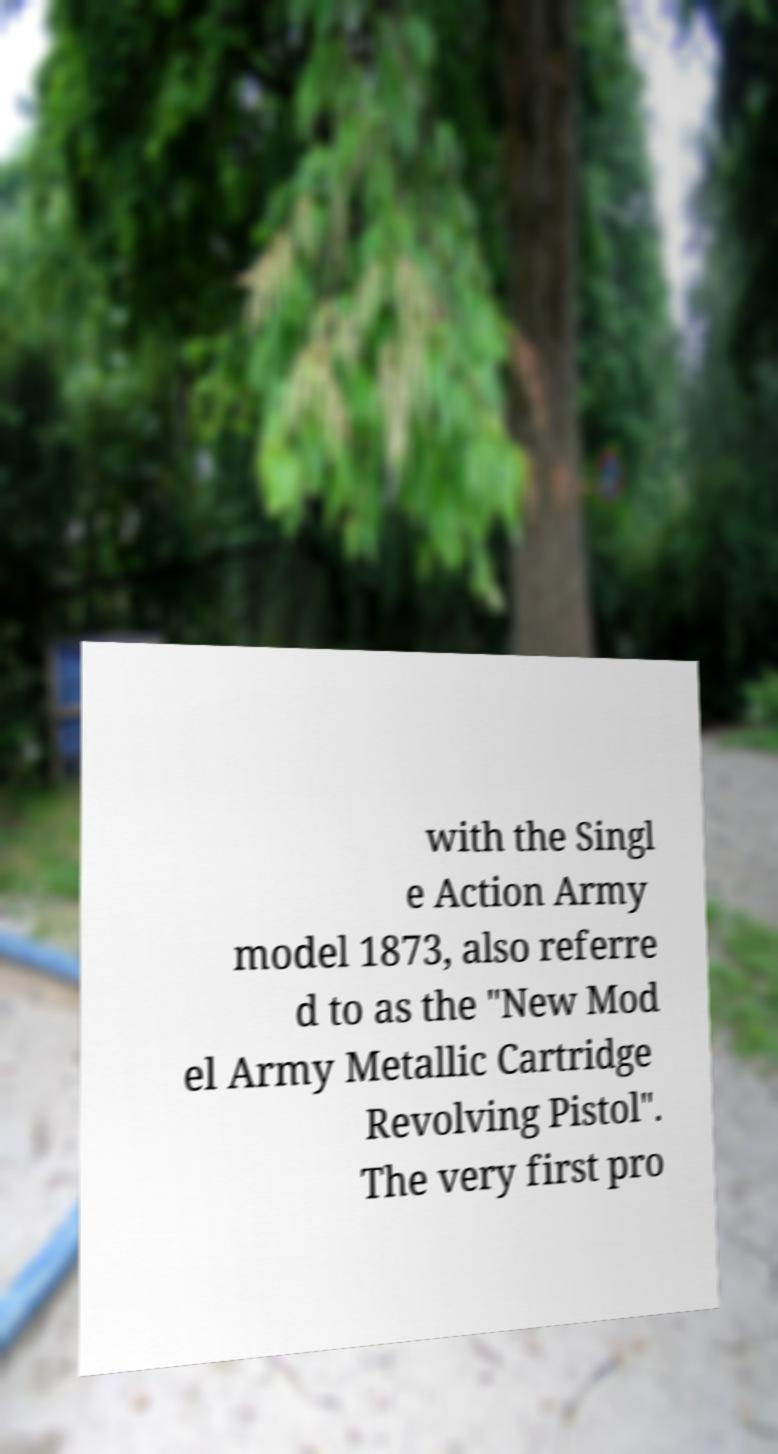Could you extract and type out the text from this image? with the Singl e Action Army model 1873, also referre d to as the "New Mod el Army Metallic Cartridge Revolving Pistol". The very first pro 